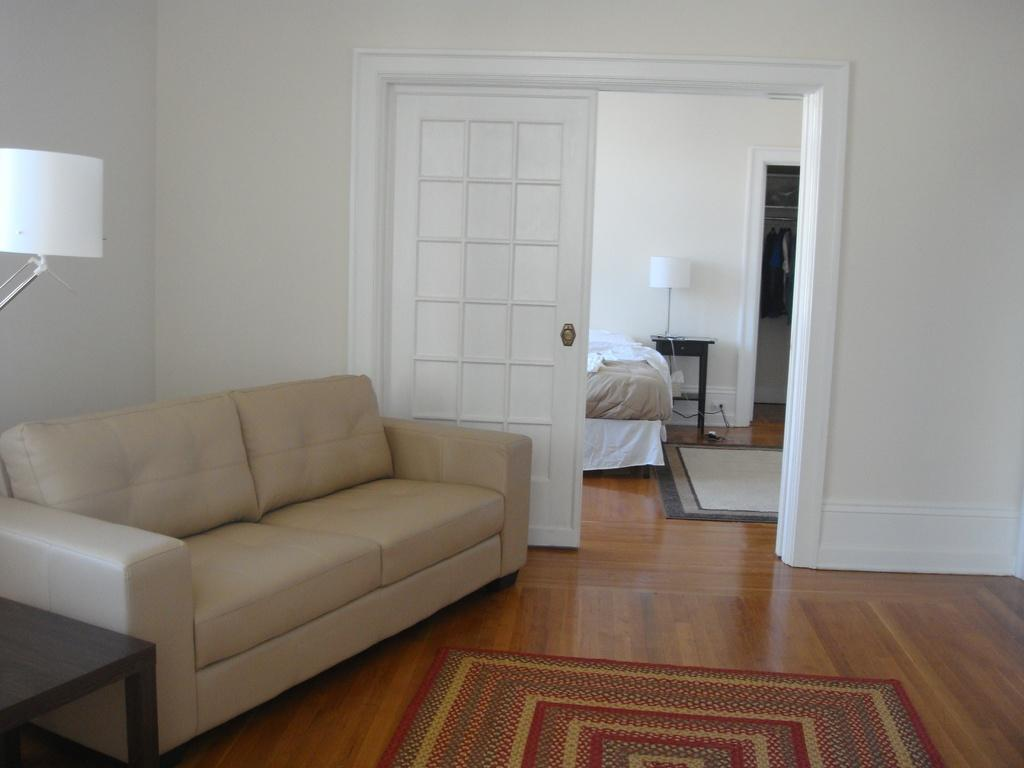What type of furniture is located in the left corner of the image? There is a cream-colored sofa in the left corner of the image. What color are the walls in the image? The walls in the image are white. What color are the doors in the image? The doors in the image are white. What color is the floor in the image? The floor in the image is brown. What type of grass can be seen growing on the protest in the image? There is no grass or protest present in the image; it features a cream-colored sofa, white walls and doors, and a brown floor. How many grapes are visible on the grape vine in the image? There is no grape vine or grapes present in the image. 